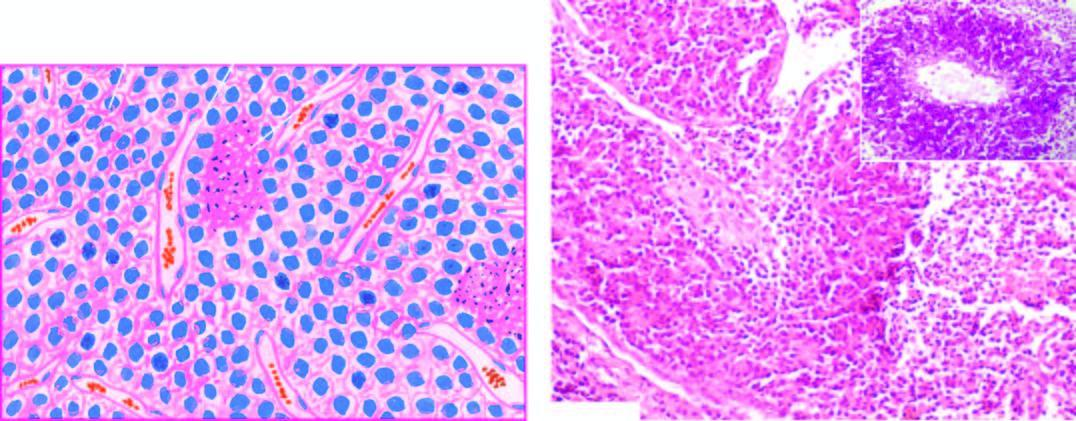what are also included?
Answer the question using a single word or phrase. Areas of necrosis and inflammatory infiltrate 